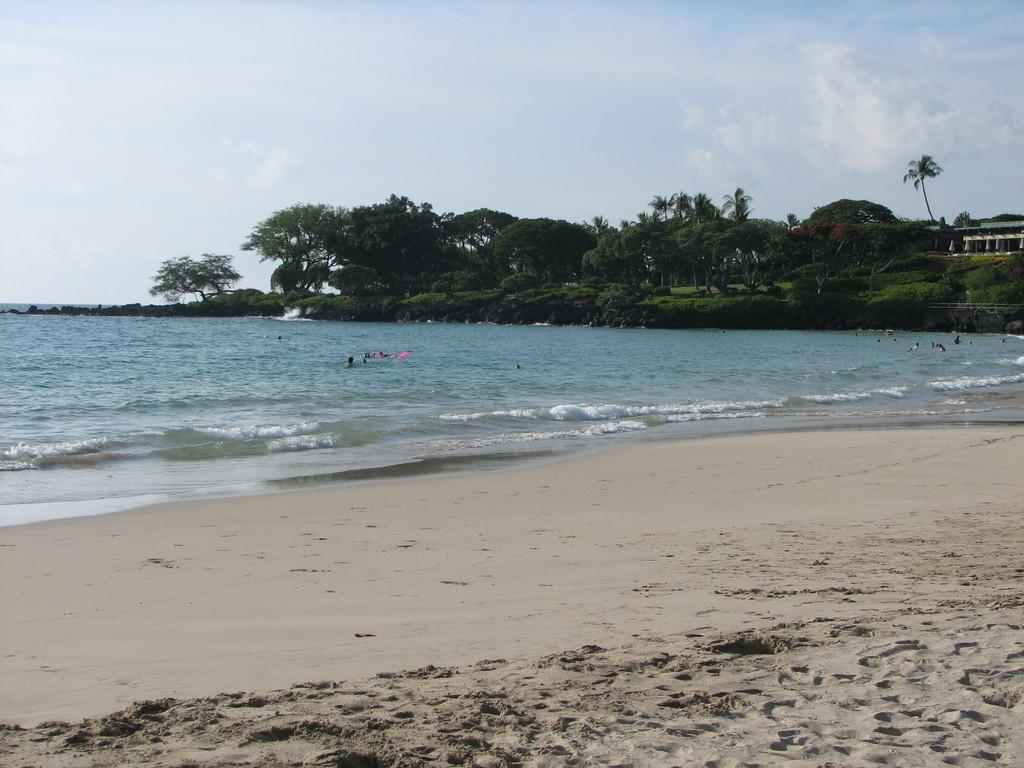What is one of the main elements in the image? There is water in the image. What else can be seen in the image besides water? There are trees and a building in the image. What are the people in the water doing? People are swimming in the water. How would you describe the sky in the image? The sky is blue and cloudy. Where is the fireman wearing a mask in the alley in the image? There is no fireman wearing a mask in an alley present in the image. 